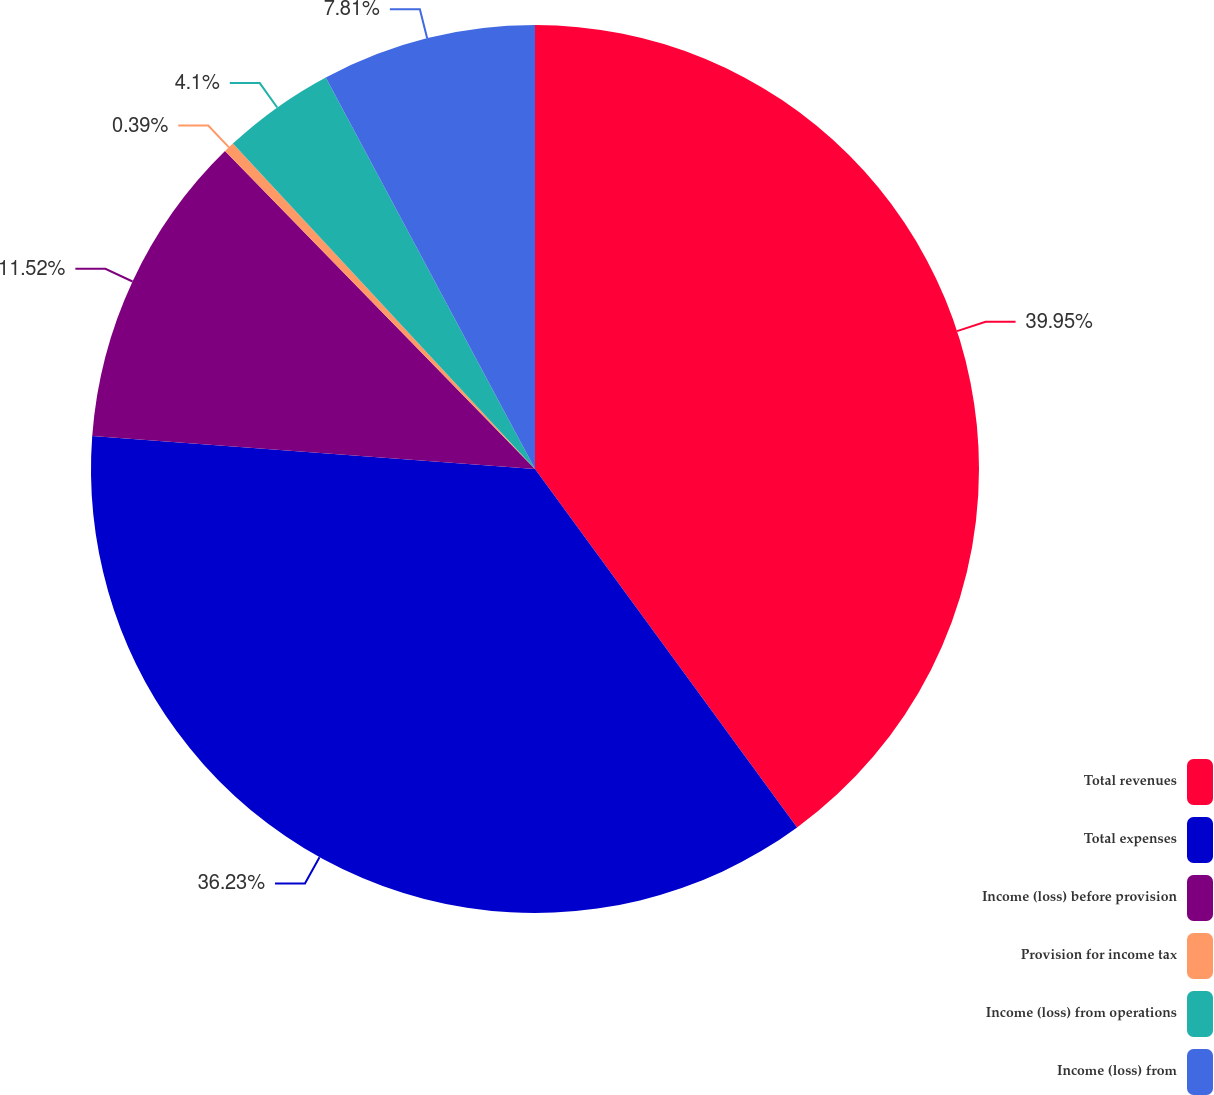Convert chart. <chart><loc_0><loc_0><loc_500><loc_500><pie_chart><fcel>Total revenues<fcel>Total expenses<fcel>Income (loss) before provision<fcel>Provision for income tax<fcel>Income (loss) from operations<fcel>Income (loss) from<nl><fcel>39.95%<fcel>36.23%<fcel>11.52%<fcel>0.39%<fcel>4.1%<fcel>7.81%<nl></chart> 